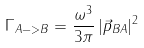Convert formula to latex. <formula><loc_0><loc_0><loc_500><loc_500>\Gamma _ { A - > B } = \frac { \omega ^ { 3 } } { 3 \pi } \, | \vec { p } _ { B A } | ^ { 2 }</formula> 